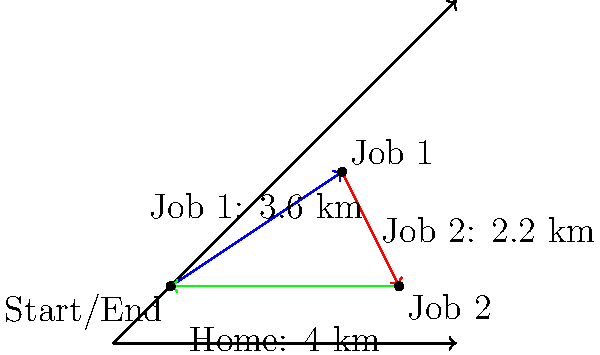A single mother works two jobs to support her family. She travels 3.6 km northeast to her first job, then 2.2 km southeast to her second job, and finally 4 km west to return home. Using vector addition, calculate the total distance she travels in her daily commute. Let's approach this step-by-step:

1) First, we need to represent each leg of the journey as a vector:
   - Vector 1 (v₁): 3.6 km northeast
   - Vector 2 (v₂): 2.2 km southeast
   - Vector 3 (v₃): 4 km west

2) To find the total distance, we need to add these vectors and then calculate the magnitude of the resulting vector.

3) We can break down the northeast and southeast vectors into their x and y components:
   - v₁: 3.6 km at 45° = (3.6 * cos 45°, 3.6 * sin 45°) = (2.55, 2.55) km
   - v₂: 2.2 km at -45° = (2.2 * cos(-45°), 2.2 * sin(-45°)) = (1.56, -1.56) km
   - v₃: 4 km west = (-4, 0) km

4) Now we can add these vectors:
   Total vector = v₁ + v₂ + v₃
                = (2.55, 2.55) + (1.56, -1.56) + (-4, 0)
                = (0.11, 0.99) km

5) To find the magnitude (length) of this vector, we use the Pythagorean theorem:
   Distance = $\sqrt{(0.11)^2 + (0.99)^2}$ = $\sqrt{0.0121 + 0.9801}$ = $\sqrt{0.9922}$ = 0.996 km

6) However, this is just the straight-line distance between the start and end points. For the total distance traveled, we need to add the lengths of all three vectors:

   Total distance = 3.6 + 2.2 + 4 = 9.8 km
Answer: 9.8 km 